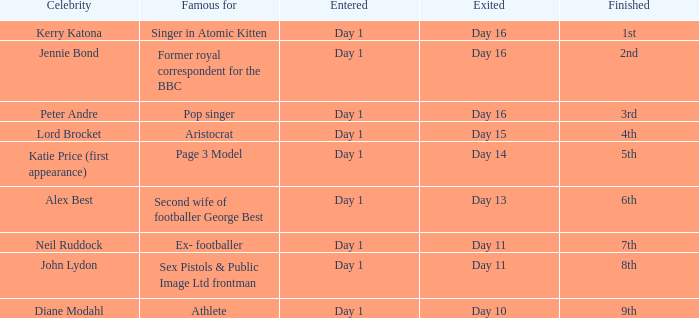Determine the finalized for exited day 13 6th. 